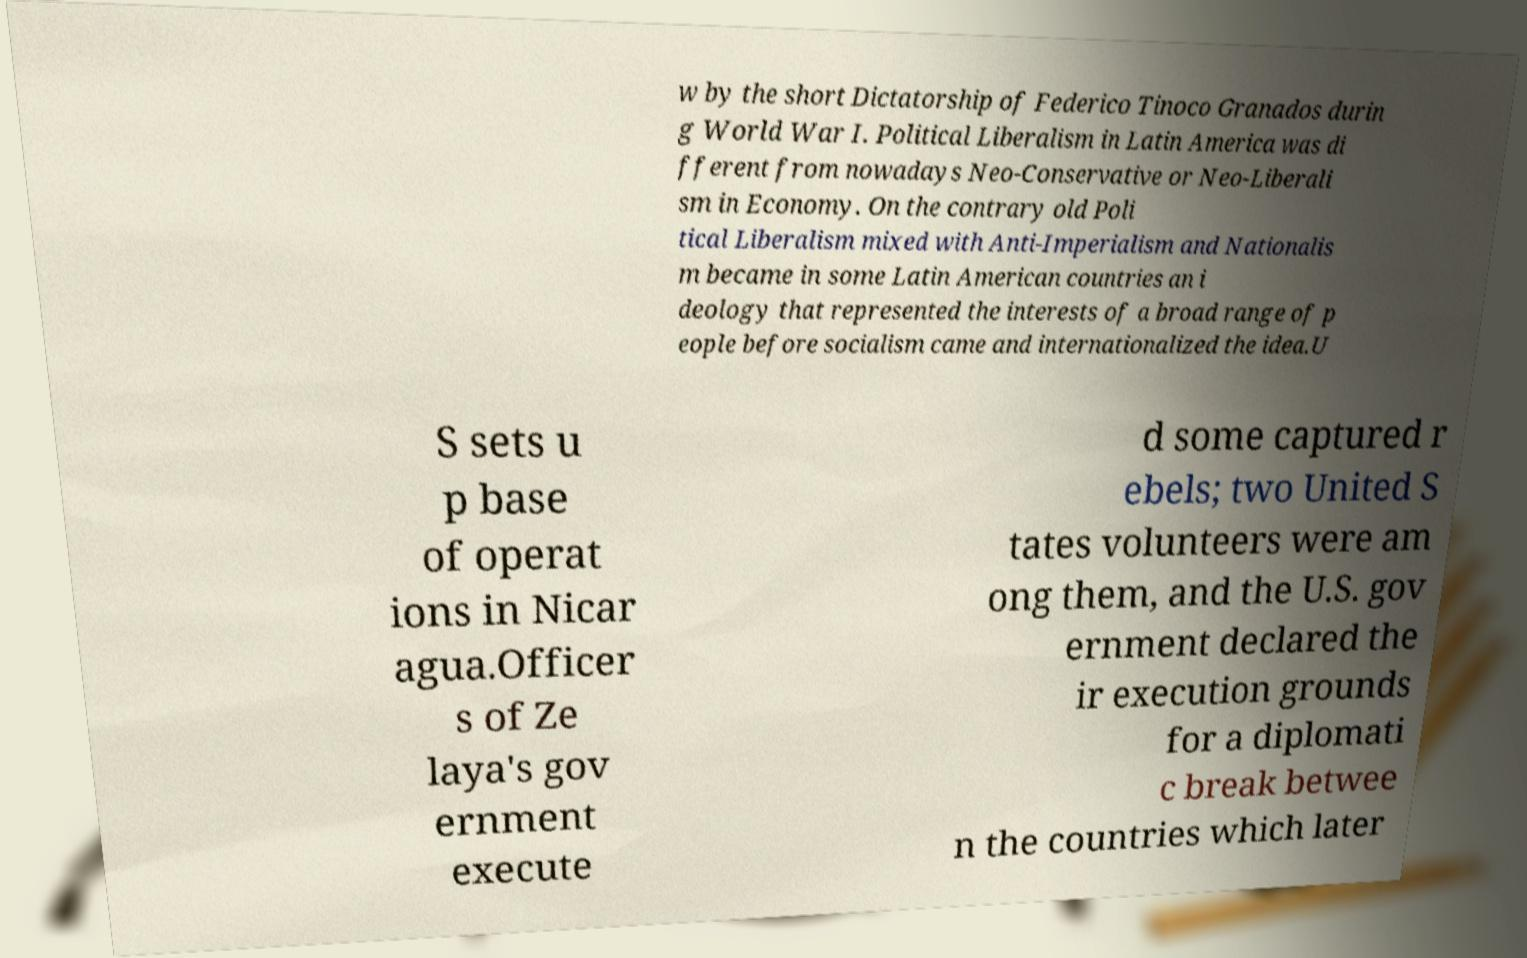Can you read and provide the text displayed in the image?This photo seems to have some interesting text. Can you extract and type it out for me? w by the short Dictatorship of Federico Tinoco Granados durin g World War I. Political Liberalism in Latin America was di fferent from nowadays Neo-Conservative or Neo-Liberali sm in Economy. On the contrary old Poli tical Liberalism mixed with Anti-Imperialism and Nationalis m became in some Latin American countries an i deology that represented the interests of a broad range of p eople before socialism came and internationalized the idea.U S sets u p base of operat ions in Nicar agua.Officer s of Ze laya's gov ernment execute d some captured r ebels; two United S tates volunteers were am ong them, and the U.S. gov ernment declared the ir execution grounds for a diplomati c break betwee n the countries which later 